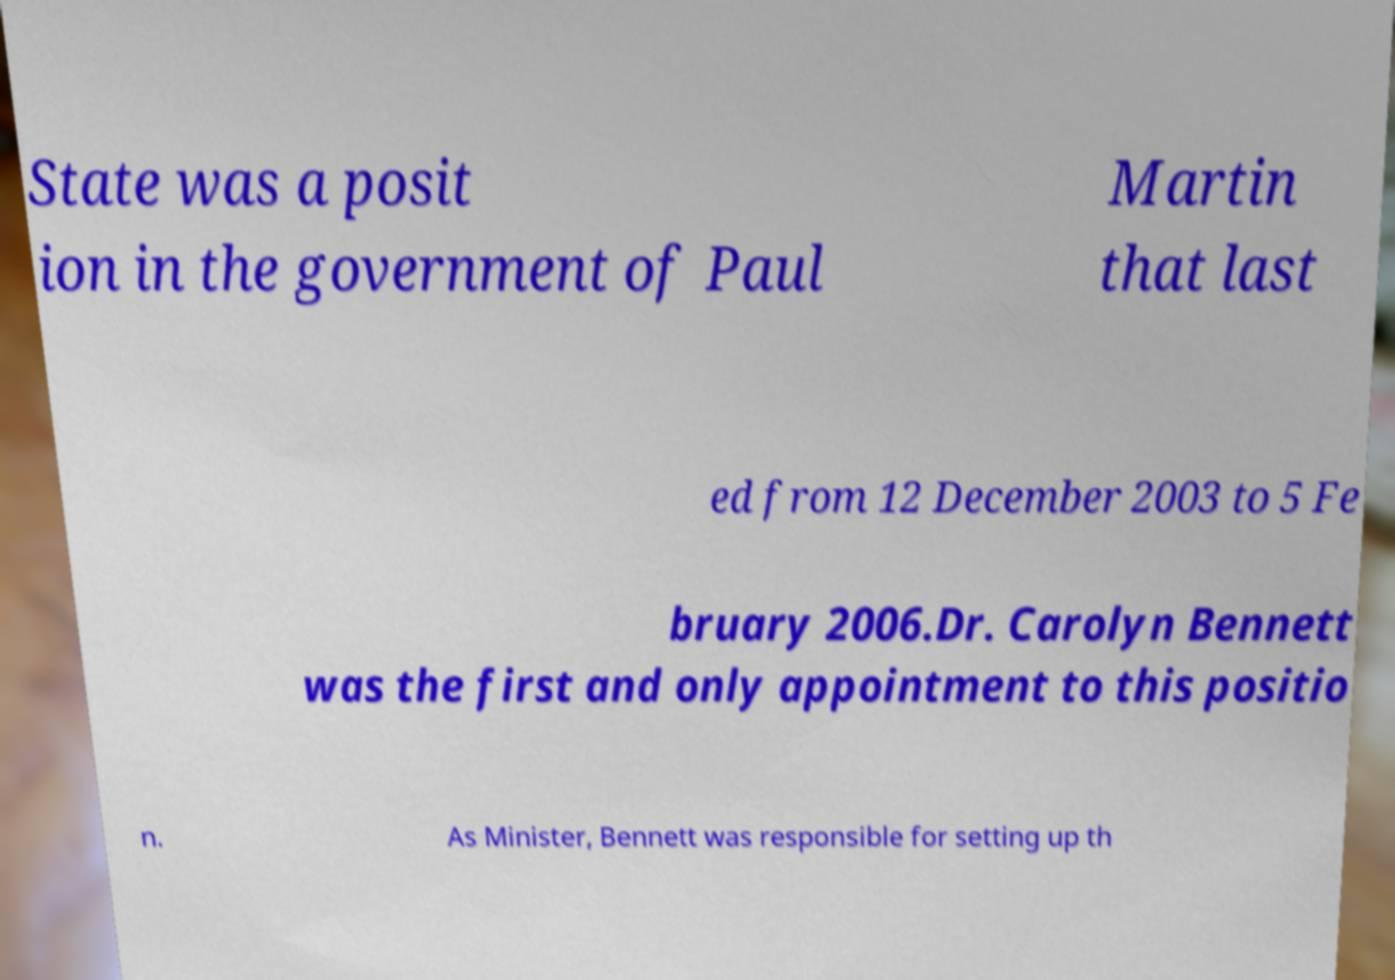Could you assist in decoding the text presented in this image and type it out clearly? State was a posit ion in the government of Paul Martin that last ed from 12 December 2003 to 5 Fe bruary 2006.Dr. Carolyn Bennett was the first and only appointment to this positio n. As Minister, Bennett was responsible for setting up th 